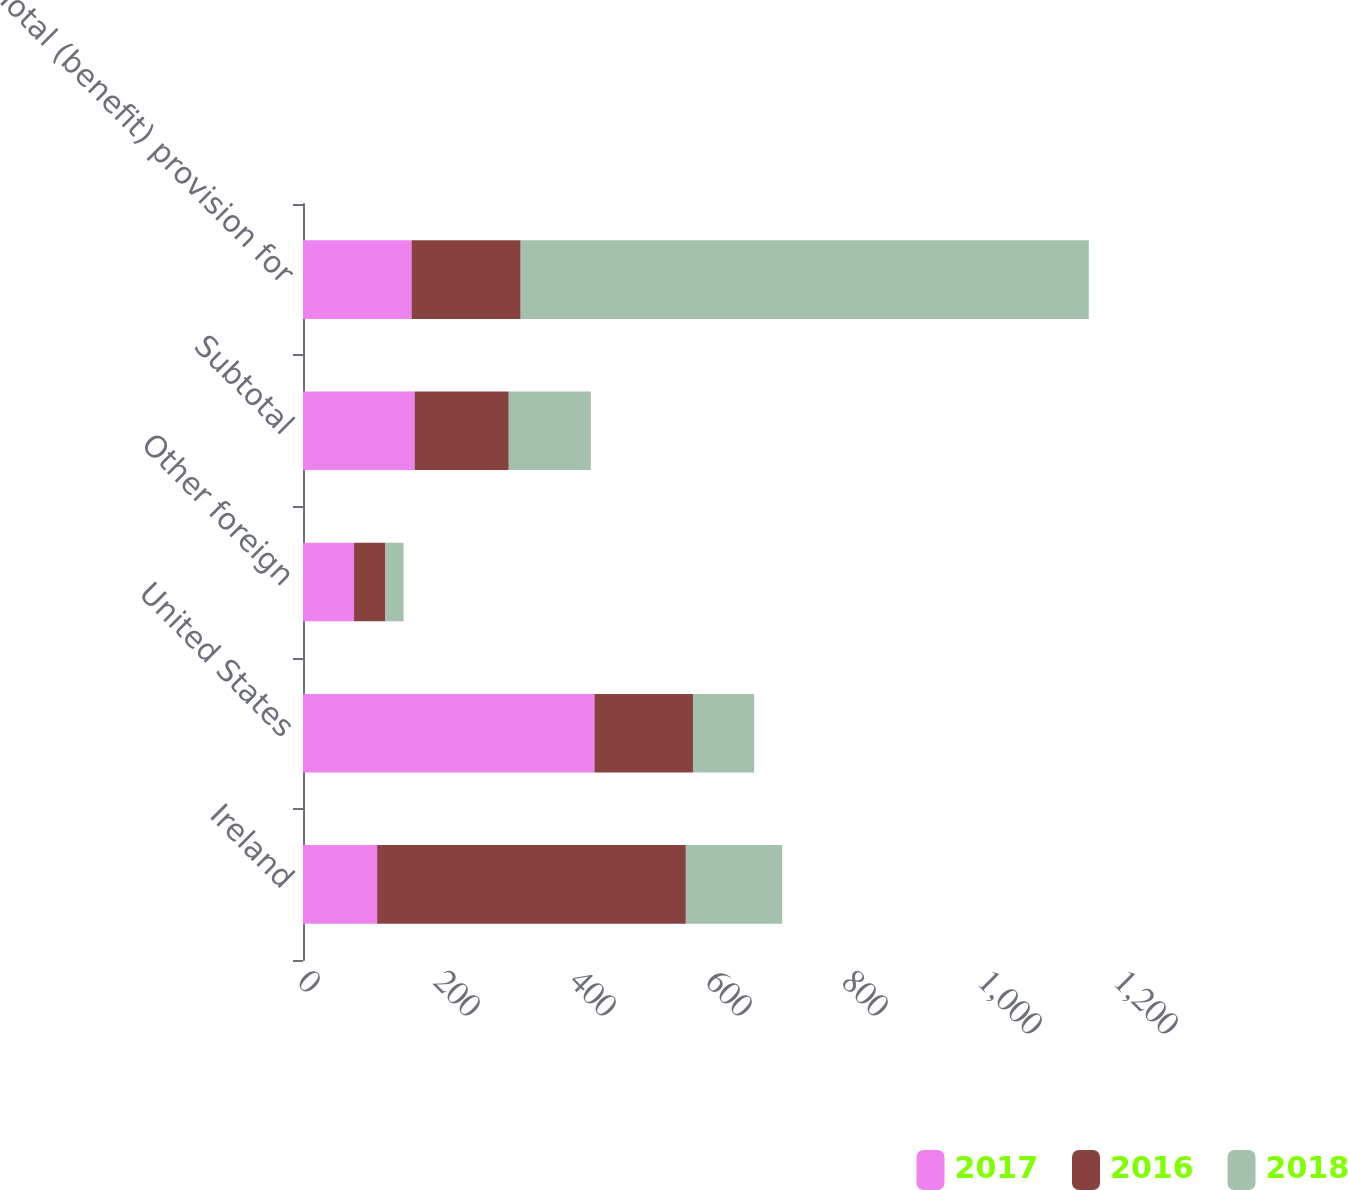Convert chart. <chart><loc_0><loc_0><loc_500><loc_500><stacked_bar_chart><ecel><fcel>Ireland<fcel>United States<fcel>Other foreign<fcel>Subtotal<fcel>Total (benefit) provision for<nl><fcel>2017<fcel>109<fcel>428.6<fcel>75.1<fcel>164.2<fcel>159.6<nl><fcel>2016<fcel>454<fcel>144.9<fcel>46.1<fcel>138.4<fcel>160.5<nl><fcel>2018<fcel>141.65<fcel>90<fcel>26.7<fcel>120.7<fcel>835.5<nl></chart> 